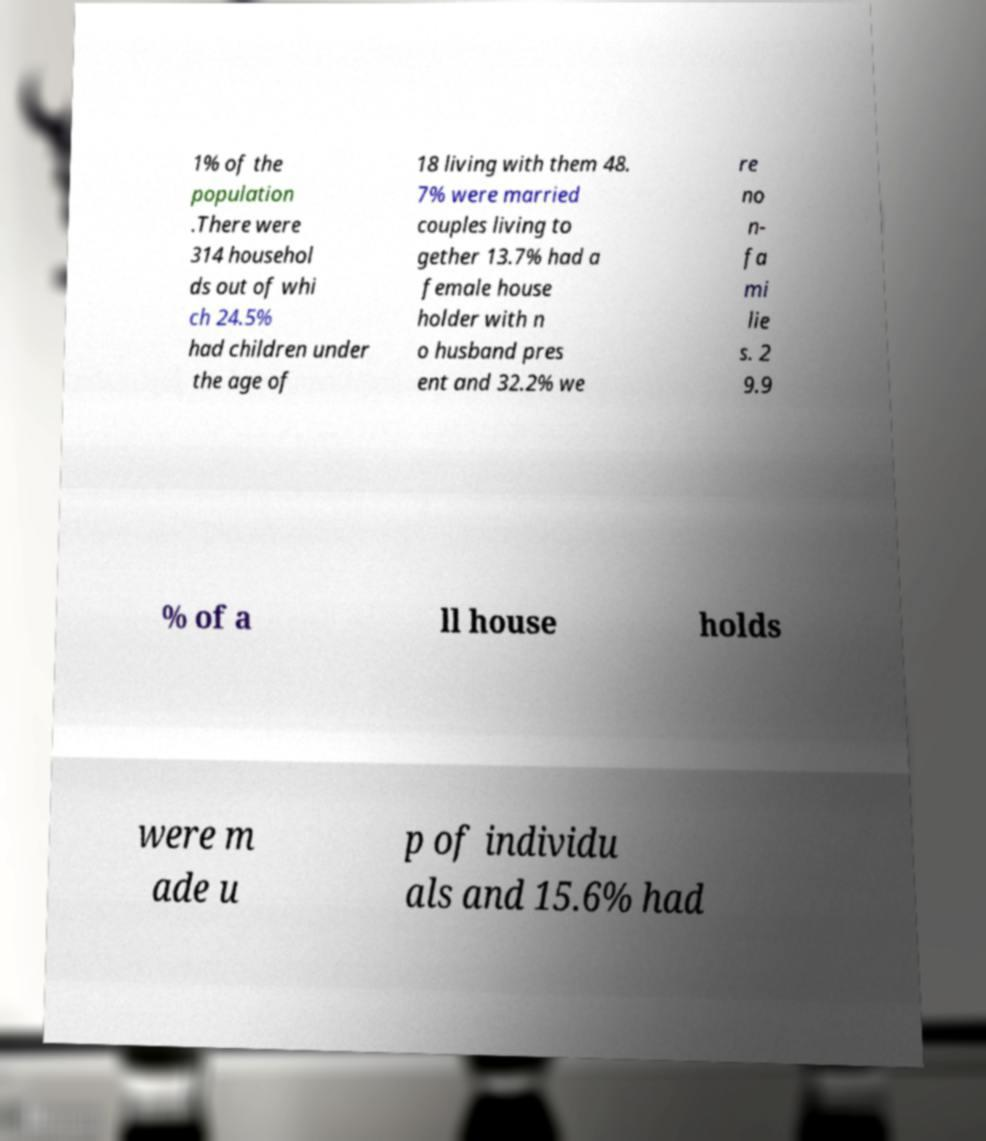Could you assist in decoding the text presented in this image and type it out clearly? 1% of the population .There were 314 househol ds out of whi ch 24.5% had children under the age of 18 living with them 48. 7% were married couples living to gether 13.7% had a female house holder with n o husband pres ent and 32.2% we re no n- fa mi lie s. 2 9.9 % of a ll house holds were m ade u p of individu als and 15.6% had 